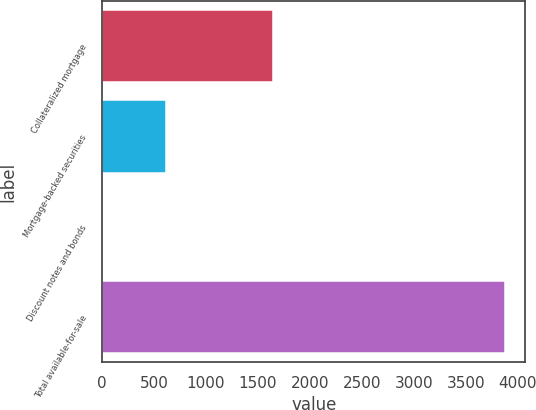<chart> <loc_0><loc_0><loc_500><loc_500><bar_chart><fcel>Collateralized mortgage<fcel>Mortgage-backed securities<fcel>Discount notes and bonds<fcel>Total available-for-sale<nl><fcel>1643<fcel>616<fcel>5<fcel>3880<nl></chart> 